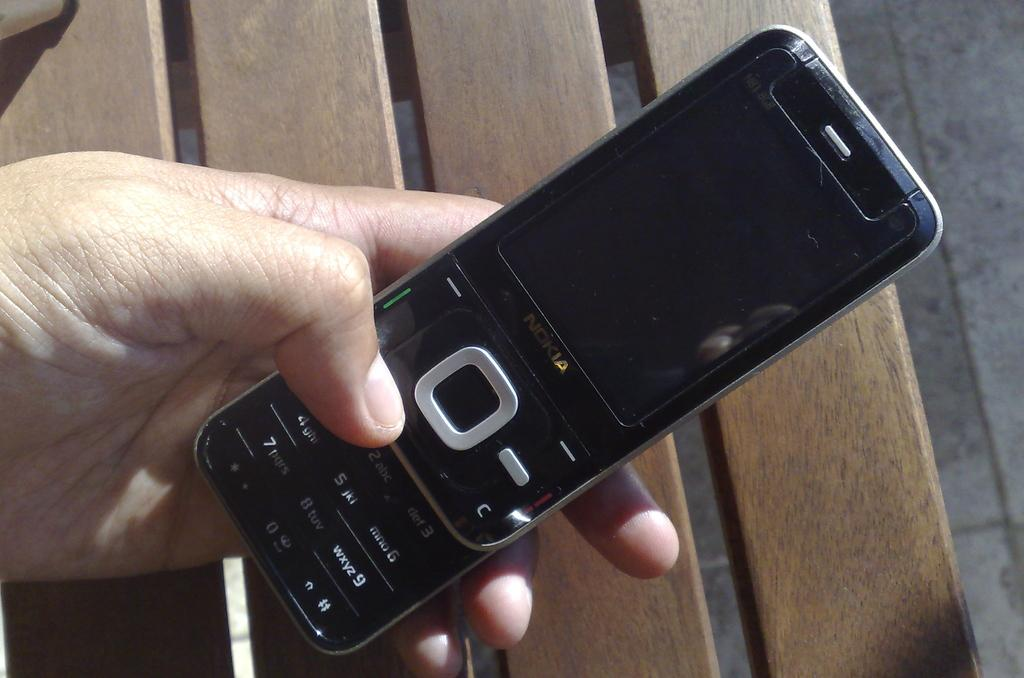<image>
Summarize the visual content of the image. a nokia phone in someone's hand in the sunlight outdoors 